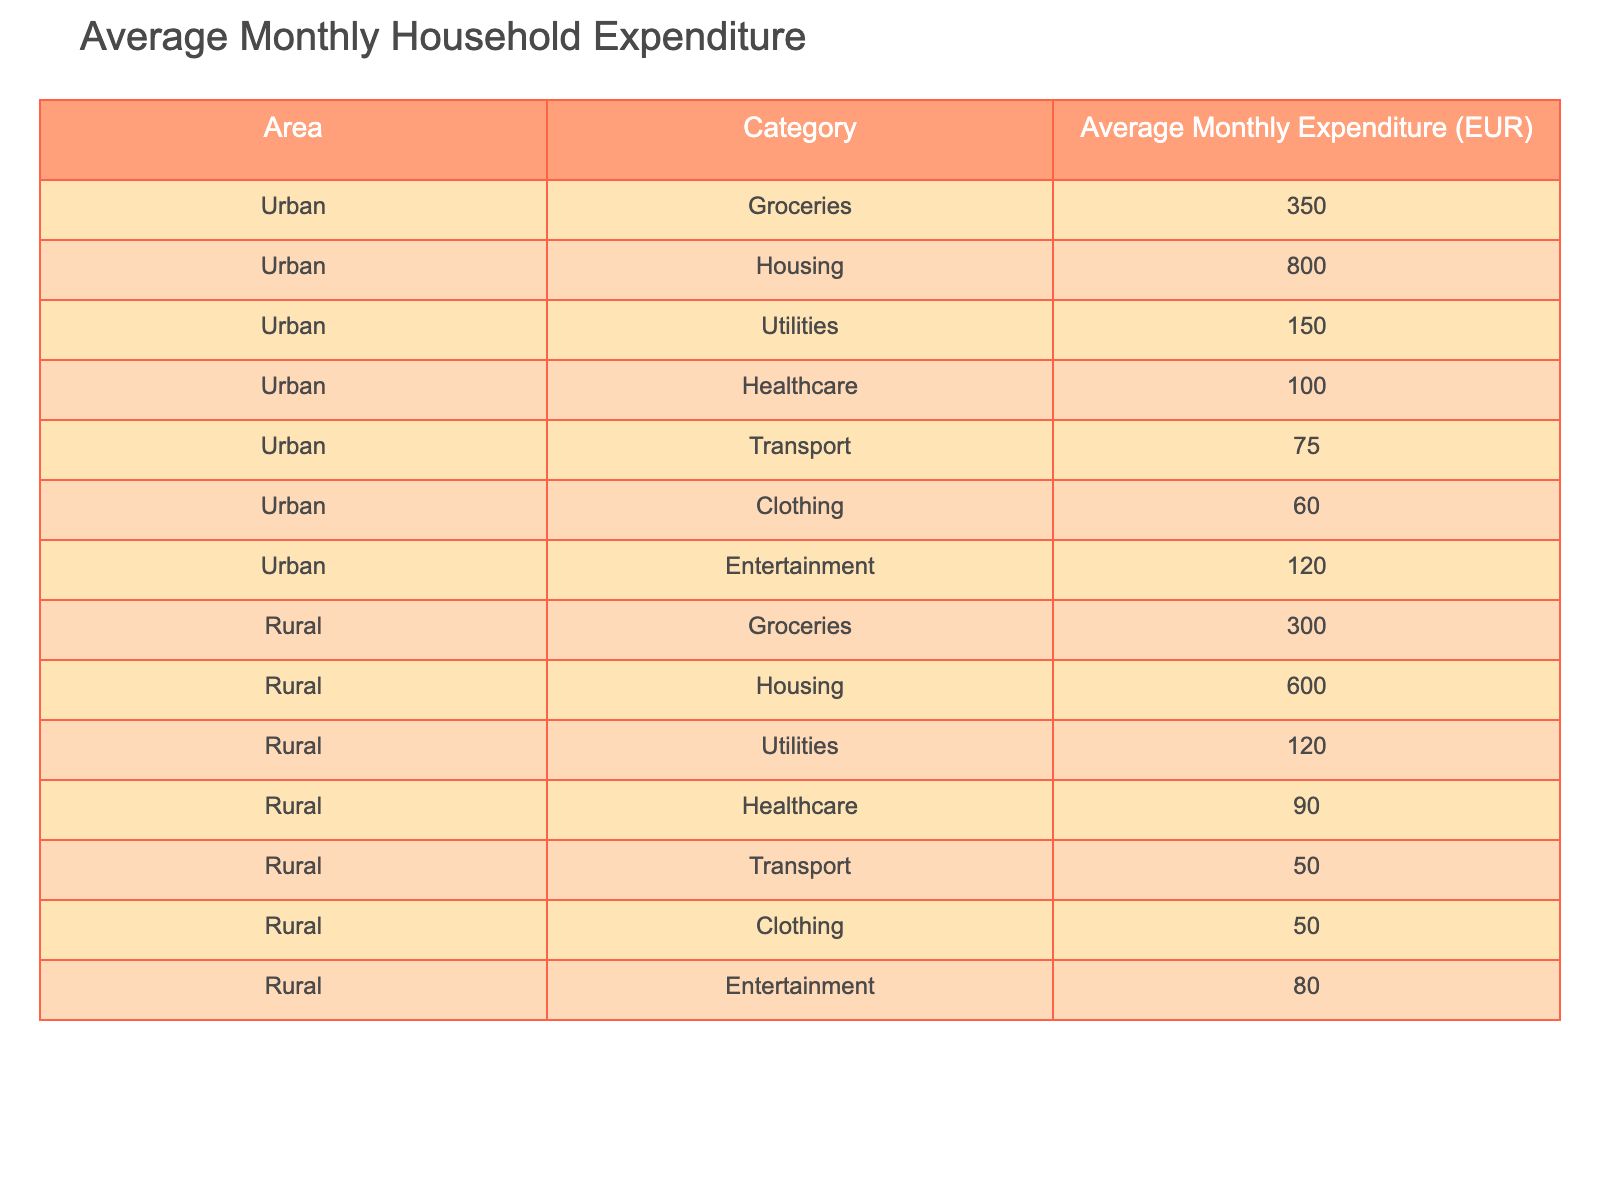What is the average monthly expenditure on groceries in urban areas? The table shows that the average monthly expenditure on groceries in urban areas is 350 EUR.
Answer: 350 EUR What is the total average monthly expenditure for urban households? To find the total average monthly expenditure for urban households, I will sum the expenditures in each category: 350 (Groceries) + 800 (Housing) + 150 (Utilities) + 100 (Healthcare) + 75 (Transport) + 60 (Clothing) + 120 (Entertainment) = 1,655 EUR.
Answer: 1,655 EUR Is the average monthly expenditure on healthcare higher in urban or rural areas? The average monthly expenditure on healthcare in urban areas is 100 EUR, while in rural areas it is 90 EUR. Since 100 EUR is greater than 90 EUR, healthcare expenditure is higher in urban areas.
Answer: Yes What is the difference in average monthly expenditure on housing between urban and rural areas? The average expenditure on housing in urban areas is 800 EUR, and in rural areas, it is 600 EUR. The difference is 800 EUR - 600 EUR = 200 EUR.
Answer: 200 EUR Which category has the lowest average monthly expenditure in urban areas? By examining the table, the lowest average expenditure in urban areas is 60 EUR, which is for Clothing.
Answer: 60 EUR What is the combined average monthly expenditure on utilities and transport in rural areas? The average monthly expenditures for utilities and transport in rural areas are 120 EUR and 50 EUR, respectively. To find the combined expenditure, I will add these two amounts: 120 EUR + 50 EUR = 170 EUR.
Answer: 170 EUR Is the average monthly expenditure on entertainment lower in urban or rural areas? The average expenditure on entertainment in urban areas is 120 EUR, while in rural areas it is 80 EUR. Since 80 EUR is less than 120 EUR, the answer is entertainment expenditure is lower in rural areas.
Answer: Yes What is the average monthly expenditure on clothing for both urban and rural households combined? To find the average, I will first sum the expenditures: 60 EUR (urban) + 50 EUR (rural) = 110 EUR, and then divide by 2 (the number of areas) to find the average: 110 EUR / 2 = 55 EUR.
Answer: 55 EUR What percentage of total monthly expenditure in urban areas is spent on housing? First, calculate the total monthly expenditure for urban areas, which is 1,655 EUR. The housing expenditure is 800 EUR. To find the percentage, I will calculate (800 EUR / 1,655 EUR) * 100% = 48.3%.
Answer: 48.3% 